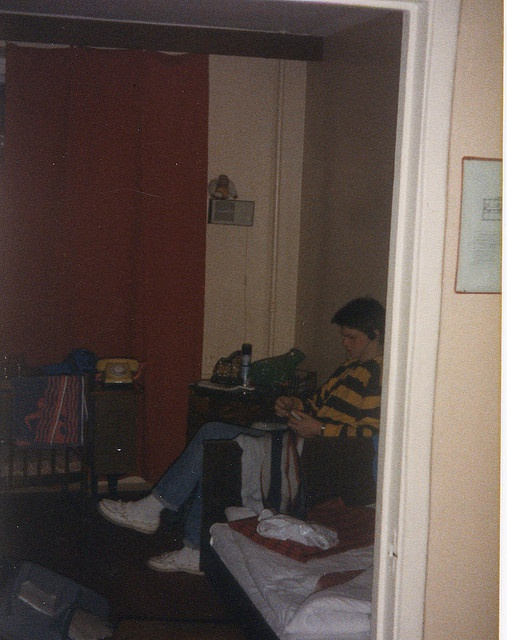Describe the objects in this image and their specific colors. I can see bed in black and gray tones, people in black, maroon, and gray tones, suitcase in black and gray tones, and cell phone in black, gray, and maroon tones in this image. 